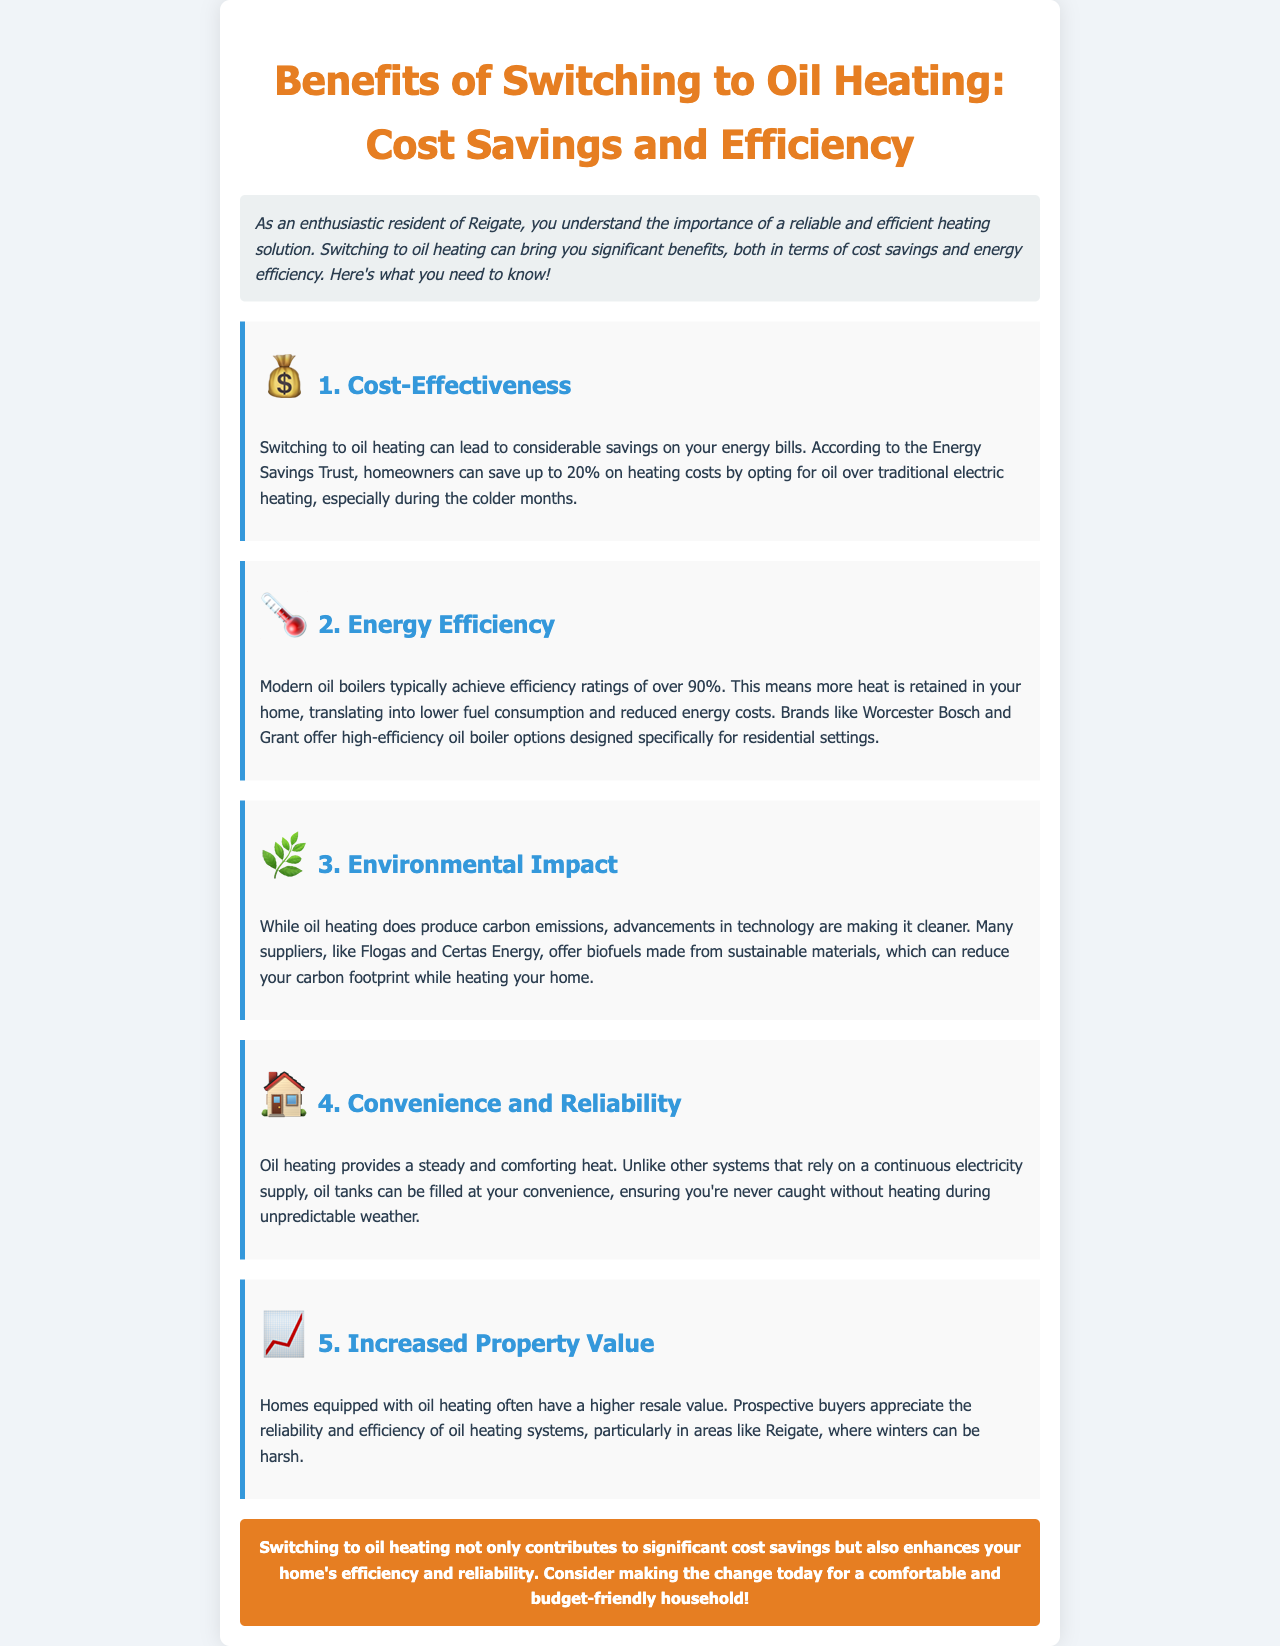What are the potential savings on heating costs? The document states that homeowners can save up to 20% on heating costs by opting for oil over traditional electric heating.
Answer: 20% What is the efficiency rating of modern oil boilers? According to the document, modern oil boilers typically achieve efficiency ratings of over 90%.
Answer: Over 90% Which brands offer high-efficiency oil boiler options? The document mentions specific brands such as Worcester Bosch and Grant that offer high-efficiency oil boiler options.
Answer: Worcester Bosch and Grant What is the primary environmental concern associated with oil heating? The document indicates that oil heating does produce carbon emissions, despite advancements in technology.
Answer: Carbon emissions How does oil heating provide reliability compared to other heating systems? The document explains that oil tanks can be filled at convenience, ensuring reliable heat without relying on continuous electricity.
Answer: Continuous electricity supply 